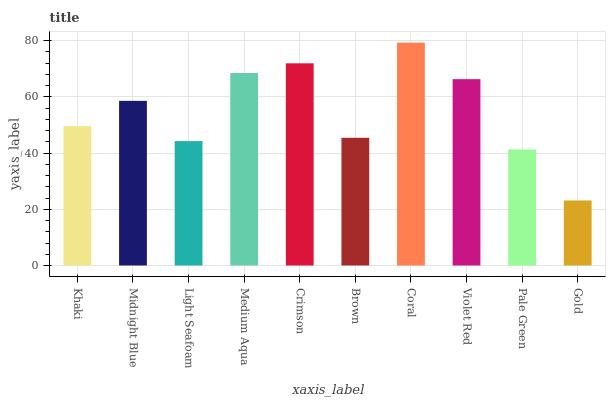Is Gold the minimum?
Answer yes or no. Yes. Is Coral the maximum?
Answer yes or no. Yes. Is Midnight Blue the minimum?
Answer yes or no. No. Is Midnight Blue the maximum?
Answer yes or no. No. Is Midnight Blue greater than Khaki?
Answer yes or no. Yes. Is Khaki less than Midnight Blue?
Answer yes or no. Yes. Is Khaki greater than Midnight Blue?
Answer yes or no. No. Is Midnight Blue less than Khaki?
Answer yes or no. No. Is Midnight Blue the high median?
Answer yes or no. Yes. Is Khaki the low median?
Answer yes or no. Yes. Is Medium Aqua the high median?
Answer yes or no. No. Is Light Seafoam the low median?
Answer yes or no. No. 